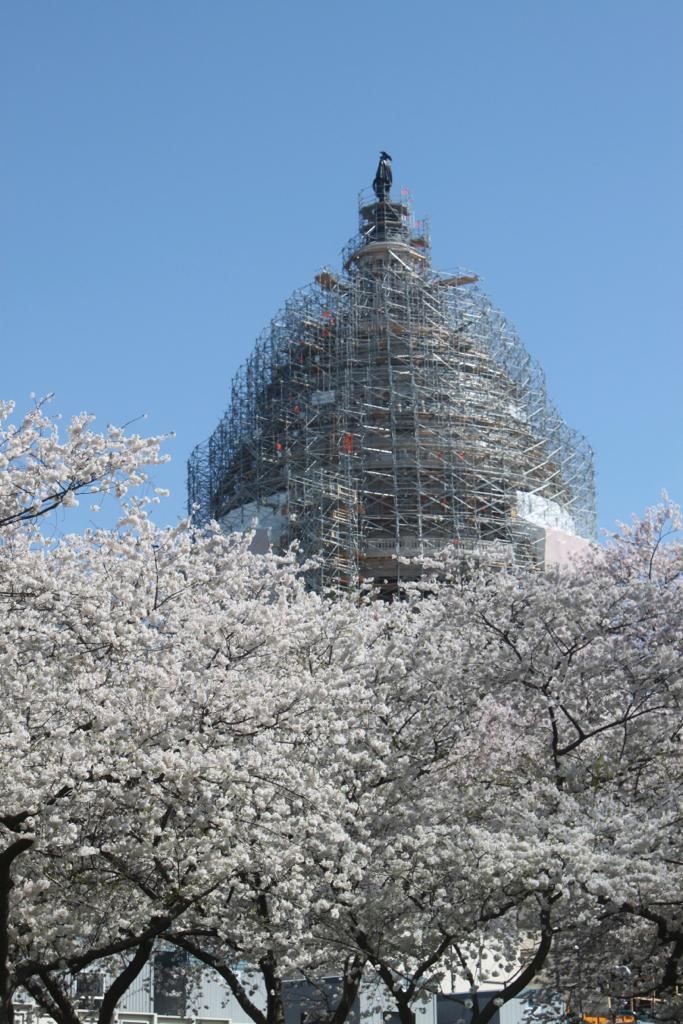What type of vegetation can be seen in the image? There are trees in the image. What is unique about the appearance of the trees? The leaves of the trees are white in color. What can be seen in the background of the image? There is a building and metal rods in the background of the image. What is visible in the sky in the image? The sky is visible in the background of the image. What type of lumber is being used to construct the building in the image? There is no information about the type of lumber used to construct the building in the image. What organization is responsible for maintaining the trees in the image? There is no information about any organization responsible for maintaining the trees in the image. 